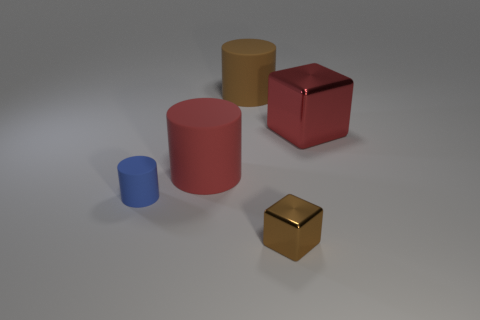Is the number of red rubber cylinders in front of the large metallic cube less than the number of small metal things that are on the left side of the small metallic cube?
Offer a terse response. No. Are there any tiny metal blocks that have the same color as the small cylinder?
Offer a very short reply. No. Are the small cylinder and the brown object behind the blue rubber cylinder made of the same material?
Your response must be concise. Yes. There is a big matte cylinder that is in front of the brown rubber object; is there a big red matte object that is in front of it?
Provide a succinct answer. No. There is a object that is in front of the red cube and on the right side of the big brown rubber cylinder; what color is it?
Your answer should be compact. Brown. What size is the red block?
Your answer should be compact. Large. How many blue objects have the same size as the red matte object?
Make the answer very short. 0. Is the large cylinder that is on the left side of the large brown cylinder made of the same material as the object that is behind the large red metallic thing?
Your answer should be compact. Yes. The large cylinder on the right side of the large rubber thing that is left of the brown matte thing is made of what material?
Provide a succinct answer. Rubber. What material is the large brown cylinder that is behind the red cylinder?
Provide a short and direct response. Rubber. 